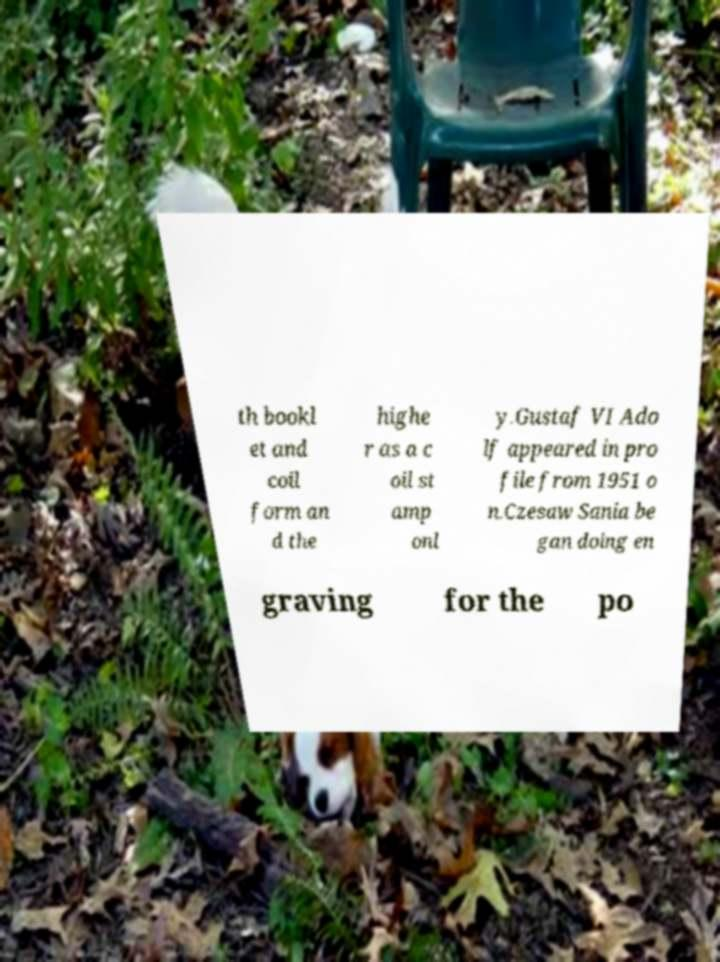There's text embedded in this image that I need extracted. Can you transcribe it verbatim? th bookl et and coil form an d the highe r as a c oil st amp onl y.Gustaf VI Ado lf appeared in pro file from 1951 o n.Czesaw Sania be gan doing en graving for the po 